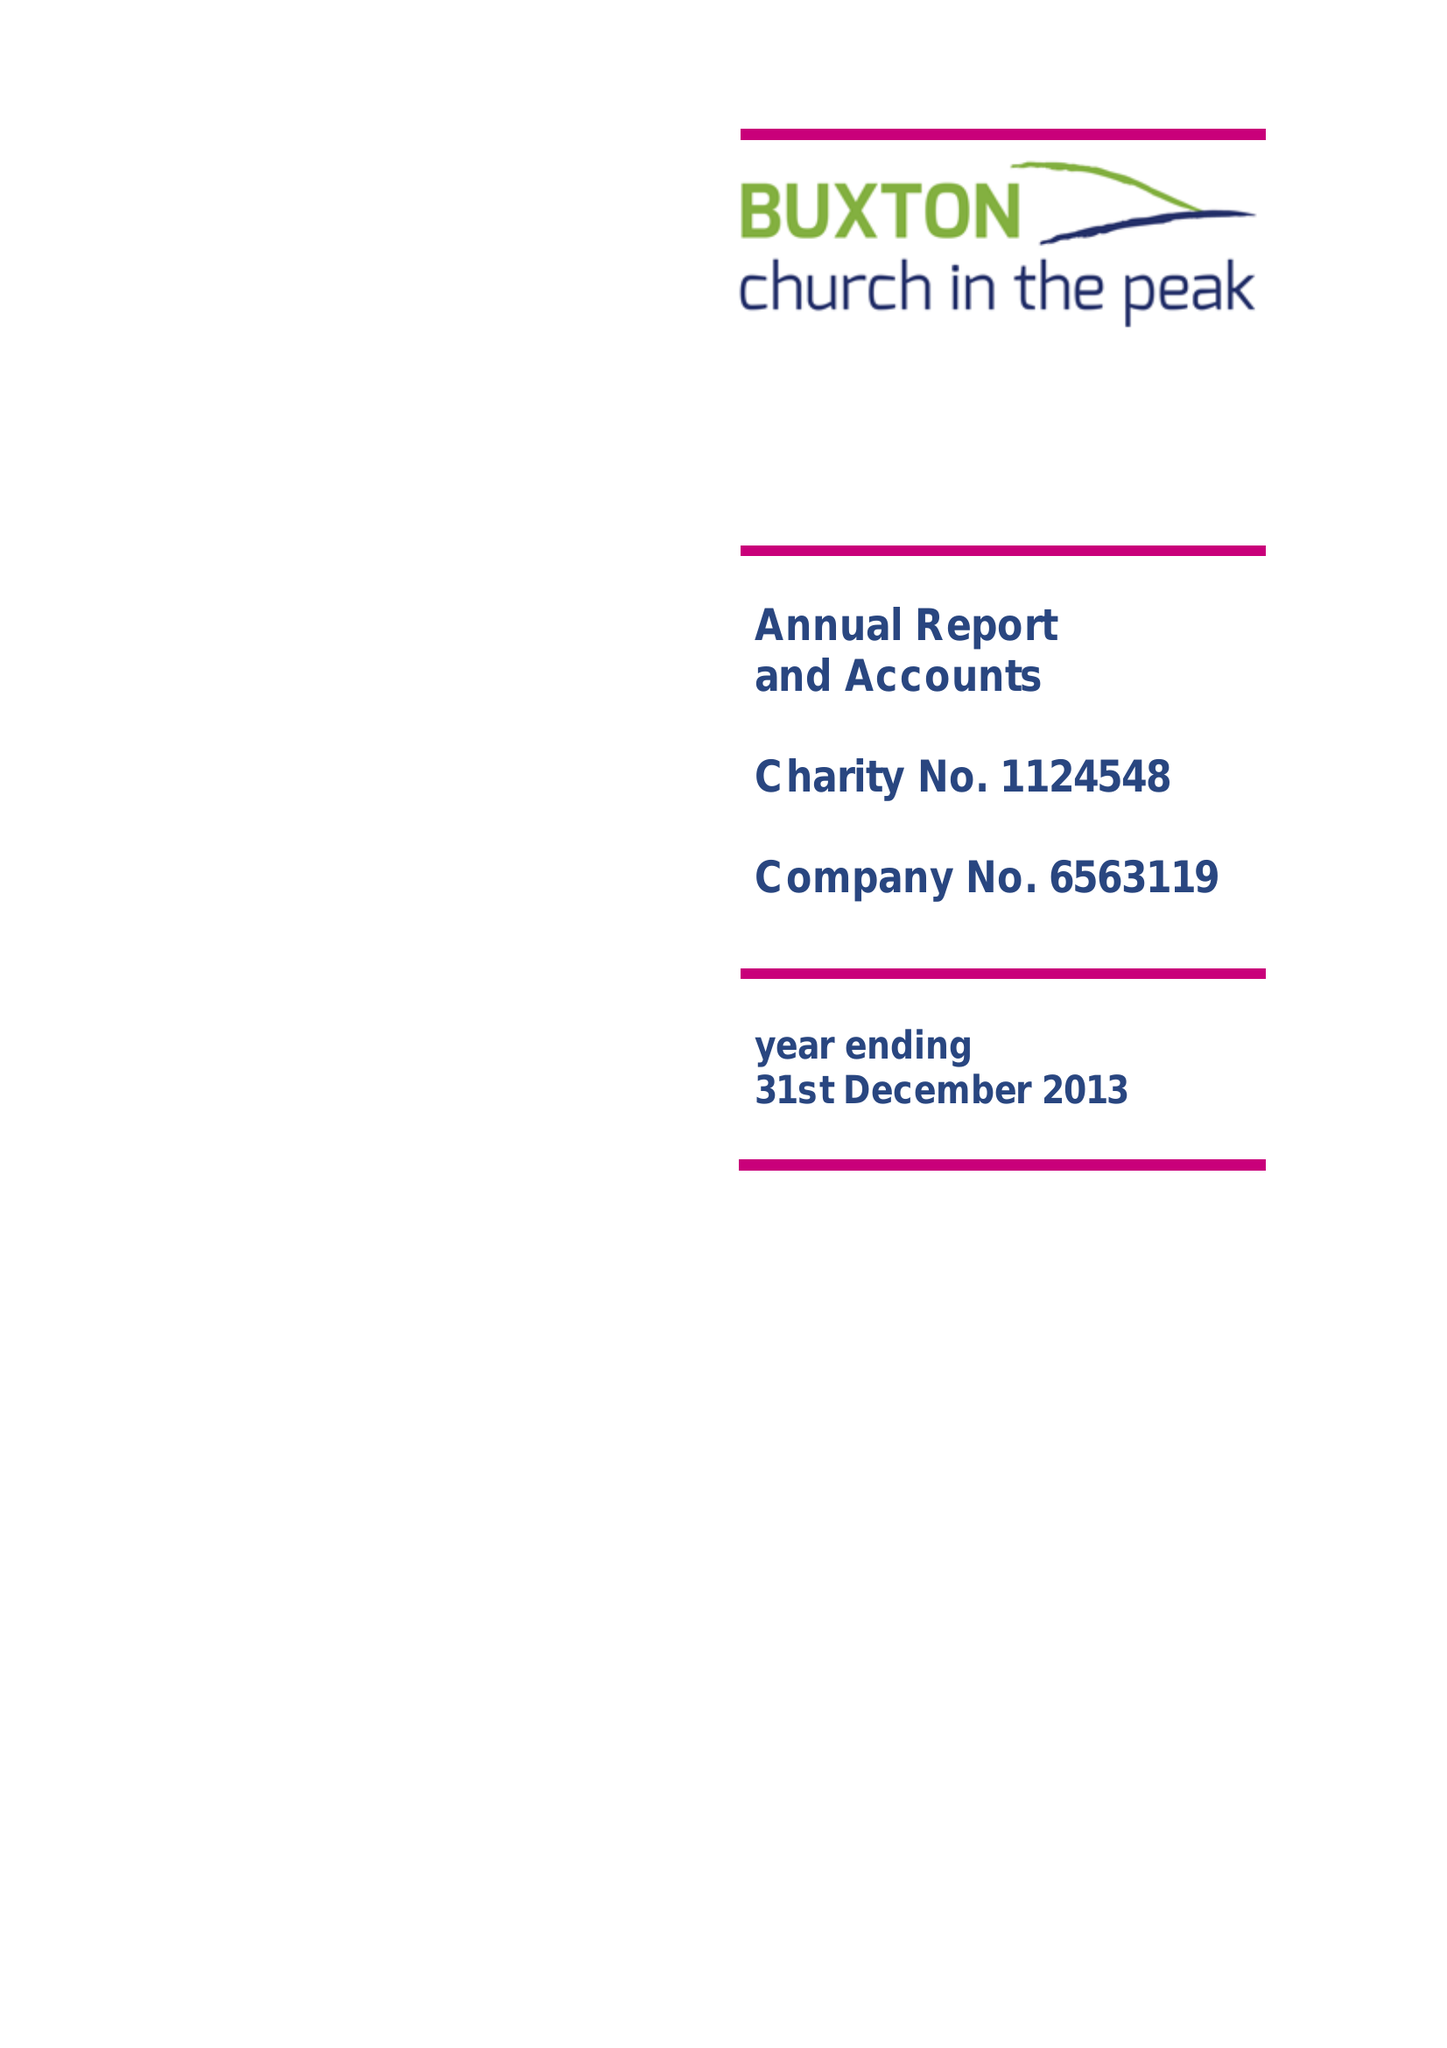What is the value for the spending_annually_in_british_pounds?
Answer the question using a single word or phrase. 107058.00 